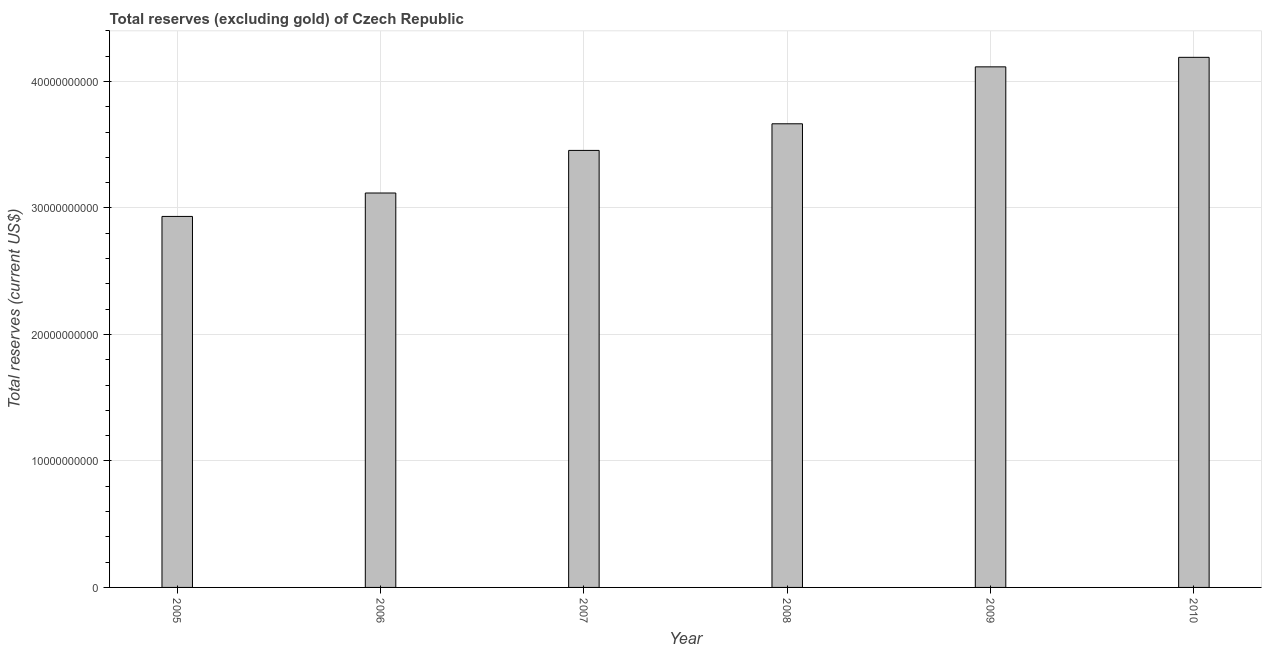Does the graph contain any zero values?
Make the answer very short. No. What is the title of the graph?
Ensure brevity in your answer.  Total reserves (excluding gold) of Czech Republic. What is the label or title of the Y-axis?
Your answer should be very brief. Total reserves (current US$). What is the total reserves (excluding gold) in 2007?
Keep it short and to the point. 3.45e+1. Across all years, what is the maximum total reserves (excluding gold)?
Your answer should be very brief. 4.19e+1. Across all years, what is the minimum total reserves (excluding gold)?
Your answer should be very brief. 2.93e+1. What is the sum of the total reserves (excluding gold)?
Your answer should be very brief. 2.15e+11. What is the difference between the total reserves (excluding gold) in 2007 and 2009?
Give a very brief answer. -6.61e+09. What is the average total reserves (excluding gold) per year?
Your response must be concise. 3.58e+1. What is the median total reserves (excluding gold)?
Offer a very short reply. 3.56e+1. Do a majority of the years between 2008 and 2010 (inclusive) have total reserves (excluding gold) greater than 4000000000 US$?
Your answer should be very brief. Yes. What is the ratio of the total reserves (excluding gold) in 2006 to that in 2007?
Your answer should be very brief. 0.9. Is the total reserves (excluding gold) in 2005 less than that in 2008?
Your response must be concise. Yes. Is the difference between the total reserves (excluding gold) in 2006 and 2010 greater than the difference between any two years?
Offer a terse response. No. What is the difference between the highest and the second highest total reserves (excluding gold)?
Provide a succinct answer. 7.52e+08. Is the sum of the total reserves (excluding gold) in 2006 and 2010 greater than the maximum total reserves (excluding gold) across all years?
Keep it short and to the point. Yes. What is the difference between the highest and the lowest total reserves (excluding gold)?
Your response must be concise. 1.26e+1. In how many years, is the total reserves (excluding gold) greater than the average total reserves (excluding gold) taken over all years?
Ensure brevity in your answer.  3. How many bars are there?
Provide a succinct answer. 6. How many years are there in the graph?
Provide a succinct answer. 6. What is the difference between two consecutive major ticks on the Y-axis?
Give a very brief answer. 1.00e+1. Are the values on the major ticks of Y-axis written in scientific E-notation?
Offer a terse response. No. What is the Total reserves (current US$) in 2005?
Offer a very short reply. 2.93e+1. What is the Total reserves (current US$) of 2006?
Your answer should be very brief. 3.12e+1. What is the Total reserves (current US$) of 2007?
Offer a very short reply. 3.45e+1. What is the Total reserves (current US$) in 2008?
Offer a very short reply. 3.67e+1. What is the Total reserves (current US$) of 2009?
Offer a terse response. 4.12e+1. What is the Total reserves (current US$) of 2010?
Ensure brevity in your answer.  4.19e+1. What is the difference between the Total reserves (current US$) in 2005 and 2006?
Offer a very short reply. -1.85e+09. What is the difference between the Total reserves (current US$) in 2005 and 2007?
Your response must be concise. -5.22e+09. What is the difference between the Total reserves (current US$) in 2005 and 2008?
Keep it short and to the point. -7.32e+09. What is the difference between the Total reserves (current US$) in 2005 and 2009?
Offer a terse response. -1.18e+1. What is the difference between the Total reserves (current US$) in 2005 and 2010?
Your response must be concise. -1.26e+1. What is the difference between the Total reserves (current US$) in 2006 and 2007?
Your response must be concise. -3.37e+09. What is the difference between the Total reserves (current US$) in 2006 and 2008?
Ensure brevity in your answer.  -5.47e+09. What is the difference between the Total reserves (current US$) in 2006 and 2009?
Offer a very short reply. -9.97e+09. What is the difference between the Total reserves (current US$) in 2006 and 2010?
Offer a very short reply. -1.07e+1. What is the difference between the Total reserves (current US$) in 2007 and 2008?
Give a very brief answer. -2.10e+09. What is the difference between the Total reserves (current US$) in 2007 and 2009?
Offer a terse response. -6.61e+09. What is the difference between the Total reserves (current US$) in 2007 and 2010?
Your answer should be compact. -7.36e+09. What is the difference between the Total reserves (current US$) in 2008 and 2009?
Your answer should be compact. -4.50e+09. What is the difference between the Total reserves (current US$) in 2008 and 2010?
Keep it short and to the point. -5.25e+09. What is the difference between the Total reserves (current US$) in 2009 and 2010?
Give a very brief answer. -7.52e+08. What is the ratio of the Total reserves (current US$) in 2005 to that in 2006?
Ensure brevity in your answer.  0.94. What is the ratio of the Total reserves (current US$) in 2005 to that in 2007?
Provide a succinct answer. 0.85. What is the ratio of the Total reserves (current US$) in 2005 to that in 2008?
Provide a succinct answer. 0.8. What is the ratio of the Total reserves (current US$) in 2005 to that in 2009?
Make the answer very short. 0.71. What is the ratio of the Total reserves (current US$) in 2006 to that in 2007?
Your answer should be compact. 0.9. What is the ratio of the Total reserves (current US$) in 2006 to that in 2008?
Keep it short and to the point. 0.85. What is the ratio of the Total reserves (current US$) in 2006 to that in 2009?
Your response must be concise. 0.76. What is the ratio of the Total reserves (current US$) in 2006 to that in 2010?
Give a very brief answer. 0.74. What is the ratio of the Total reserves (current US$) in 2007 to that in 2008?
Your answer should be very brief. 0.94. What is the ratio of the Total reserves (current US$) in 2007 to that in 2009?
Make the answer very short. 0.84. What is the ratio of the Total reserves (current US$) in 2007 to that in 2010?
Provide a short and direct response. 0.82. What is the ratio of the Total reserves (current US$) in 2008 to that in 2009?
Offer a terse response. 0.89. What is the ratio of the Total reserves (current US$) in 2008 to that in 2010?
Your response must be concise. 0.88. What is the ratio of the Total reserves (current US$) in 2009 to that in 2010?
Keep it short and to the point. 0.98. 